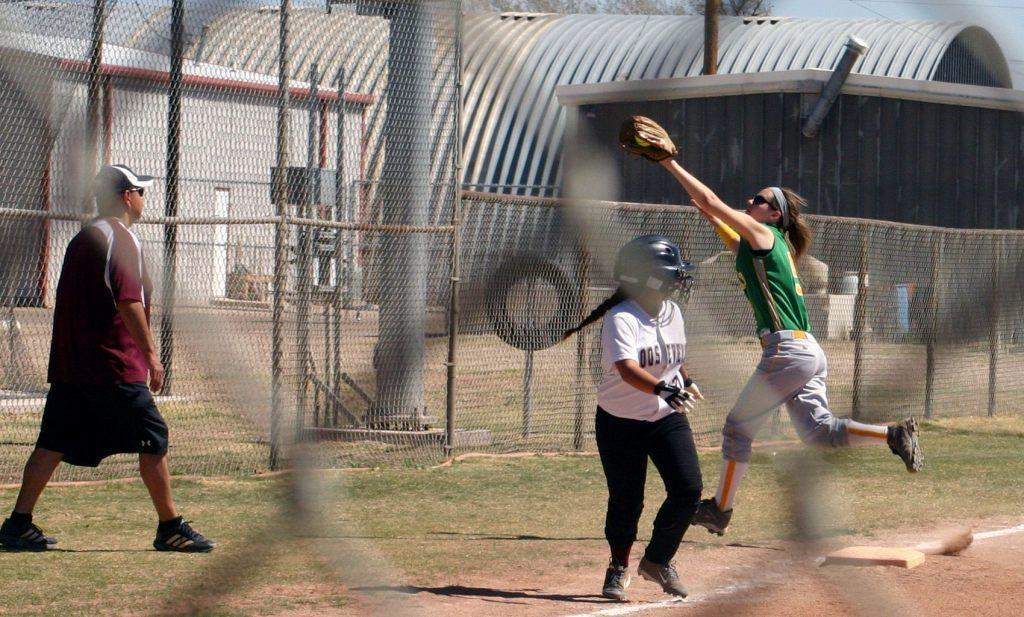How many people are in the image? There is a man and 2 girls in the image, making a total of 3 people. What are the people wearing in the image? The man and girls are wearing jerseys in the image. What type of surface is visible in the image? There is grass visible in the image. What can be seen in the background of the image? In the background of the image, there is fencing, poles, and buildings. What type of straw is being used by the man in the image? There is no straw present in the image. What color is the orange that the girls are holding in the image? There is no orange present in the image. 